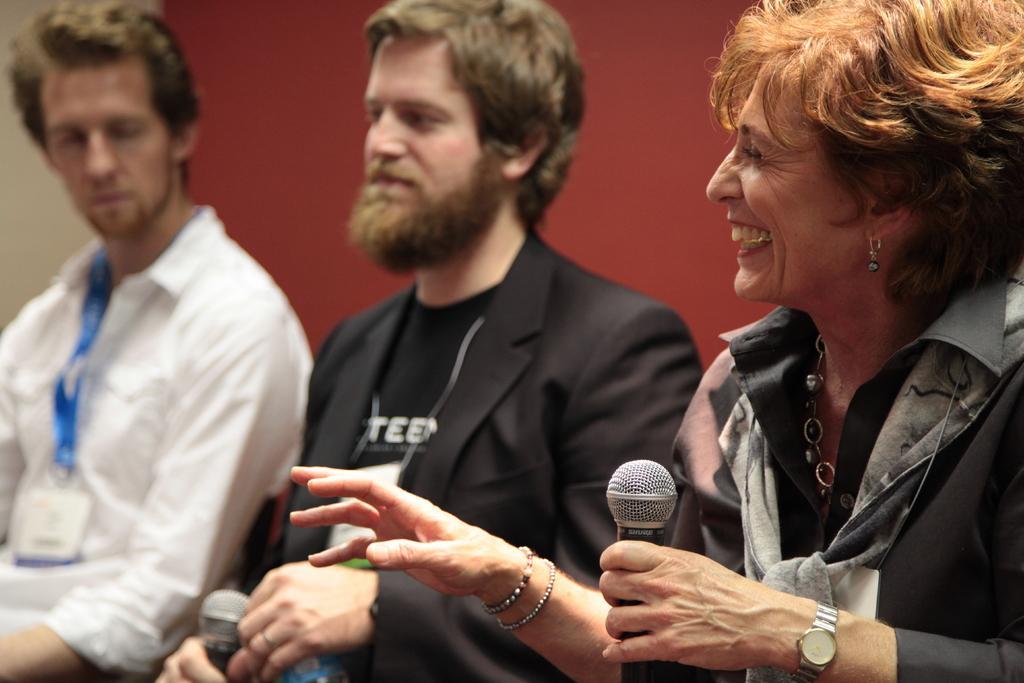In one or two sentences, can you explain what this image depicts? On the left side of an image there is a man who is wearing a white color shirt along with the ID card and also there is a person in the middle who is wearing coat the right side of an image there is a woman. She is laughing and also holding the Microphone she wear a wrist watch. 